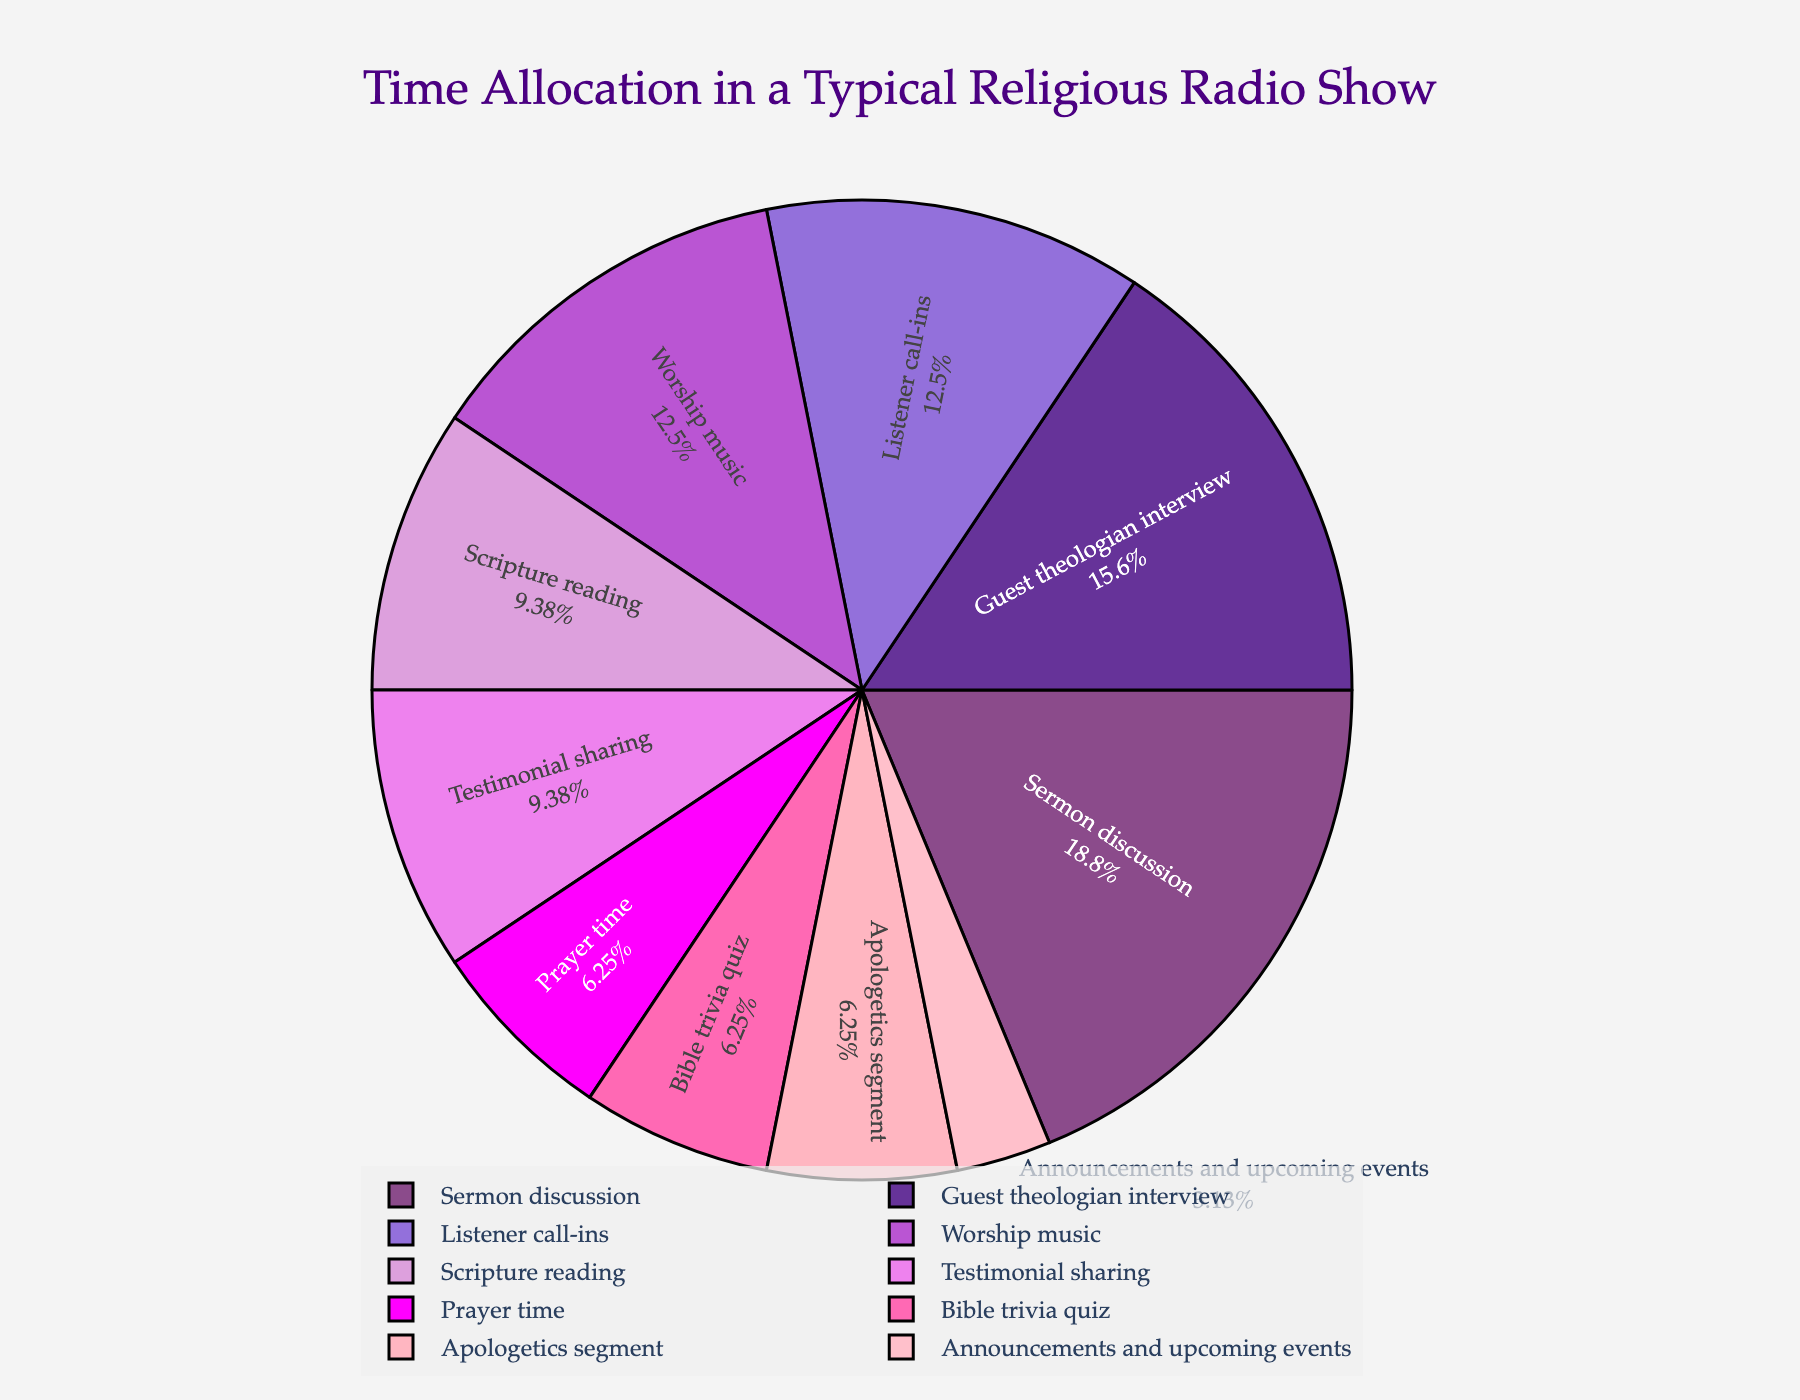What segment occupies the largest portion of the pie chart? The segment with the largest portion of the pie chart can be identified by looking for the biggest wedge. This is usually visually more conspicuous and should also have the largest percentage label. In this chart, the Sermon discussion segment is the largest.
Answer: Sermon discussion How much time in total is spent on segments that are smaller than the Sermon discussion? First, identify the duration of the Sermon discussion, which is 30 minutes. Then sum the minutes of the remaining segments: (15 + 10 + 20 + 25 + 20 + 5 + 10 + 15 + 10). This equals to 130 minutes.
Answer: 130 minutes Which segments are represented by shades of purple? Examine the pie chart for segments colored in purple shades. The Scriptural reading, Sermon discussion, Listener call-ins, and Worship music are all in shades of purple based on the provided information.
Answer: Scripture reading, Sermon discussion, Listener call-ins, Worship music If we combine the time spent on Prayer time, Apologetics segment, and Bible trivia quiz, what percentage of the total broadcast does it represent? Sum the minutes for each segment: Prayer time (10) + Apologetics segment (10) + Bible trivia quiz (10) = 30 minutes. The total broadcast time is 160 minutes, so the combined percentage is (30/160) * 100 = 18.75%.
Answer: 18.75% How does the time allocated to Guest theologian interview compare to Listener call-ins? Locate both segments on the pie chart and compare their values. Guest theologian interview takes 25 minutes, while Listener call-ins take 20 minutes. Therefore, the Guest theologian interview segment is greater.
Answer: Guest theologian interview is greater What segment has the same allocated time as the Bible trivia quiz? Check the pie chart for segments where the allocated time is equal to that of Bible trivia quiz, which is 10 minutes. The Apologetics segment and Prayer time also have 10 minutes allocated.
Answer: Prayer time, Apologetics segment Which pair of segments together accounts for the same amount of time as Sermon discussion? The Sermon discussion is 30 minutes. Identify two segments whose combined total is also 30 minutes. For example, Prayer time (10) and Testimonial sharing (15) together with Apologetics segment (10) sum to 30 minutes.
Answer: Prayer time, Testimonial sharing, Apologetics segment What is the total time spent on segments related to direct theological education (Scripture reading, Sermon discussion, Apologetics segment)? Sum the minutes of these segments: Scripture reading (15) + Sermon discussion (30) + Apologetics segment (10) = 55 minutes.
Answer: 55 minutes What is the percentage difference between Testimonial sharing and Announcements and upcoming events? Locate both segments and calculate the difference in their allocated minutes: Testimonial sharing (15) - Announcements and upcoming events (5) = 10 minutes. The total broadcast time is 160 minutes, so the percent difference is (10/160) * 100 = 6.25%.
Answer: 6.25% In terms of time allocation, which is more prioritized, Worship music or Listener call-ins? Locate both segments. Worship music is 20 minutes and Listener call-ins is also 20 minutes. Therefore, both segments are equally prioritized.
Answer: Equally prioritized 